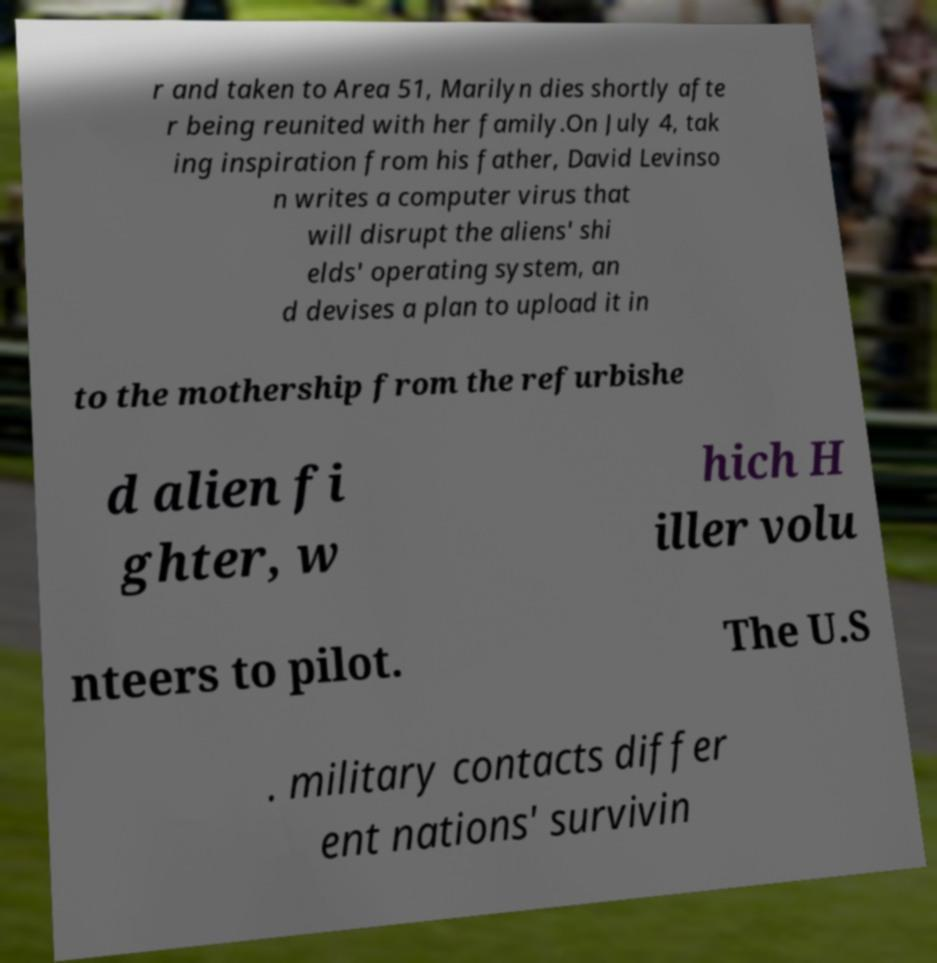Can you accurately transcribe the text from the provided image for me? r and taken to Area 51, Marilyn dies shortly afte r being reunited with her family.On July 4, tak ing inspiration from his father, David Levinso n writes a computer virus that will disrupt the aliens' shi elds' operating system, an d devises a plan to upload it in to the mothership from the refurbishe d alien fi ghter, w hich H iller volu nteers to pilot. The U.S . military contacts differ ent nations' survivin 